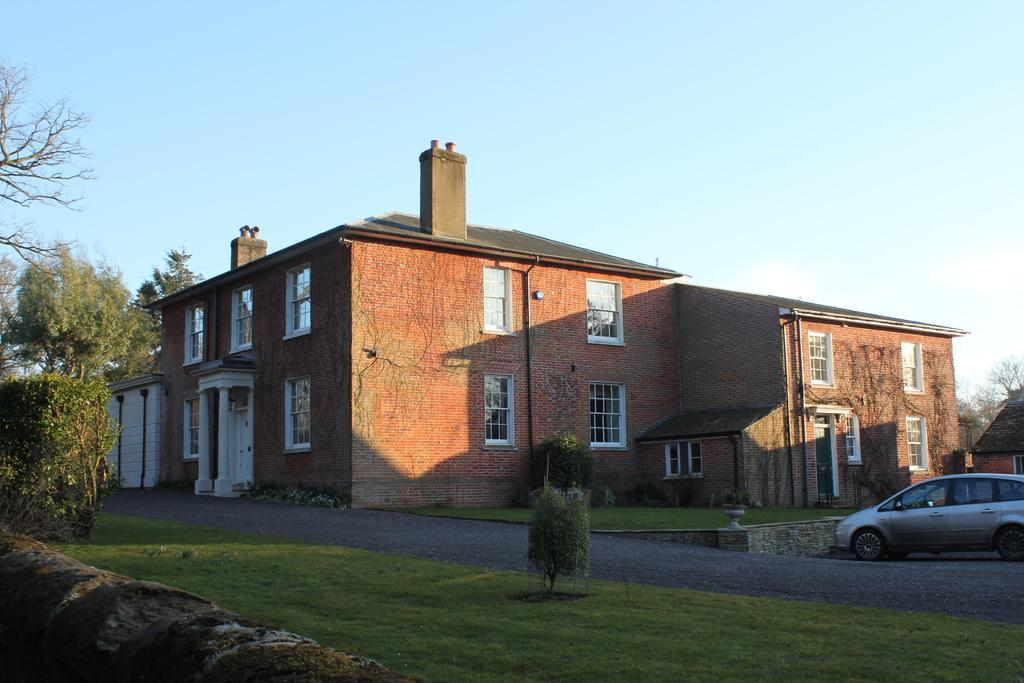What type of vegetation is present in the image? There is grass, plants, and trees in the image. What is located on the road in the image? There is a car on the road in the image. What type of structures can be seen in the image? There are buildings in the image. What is visible in the background of the image? The sky is visible in the background of the image. What type of fork is being used to distribute shame in the image? There is no fork or distribution of shame present in the image. 